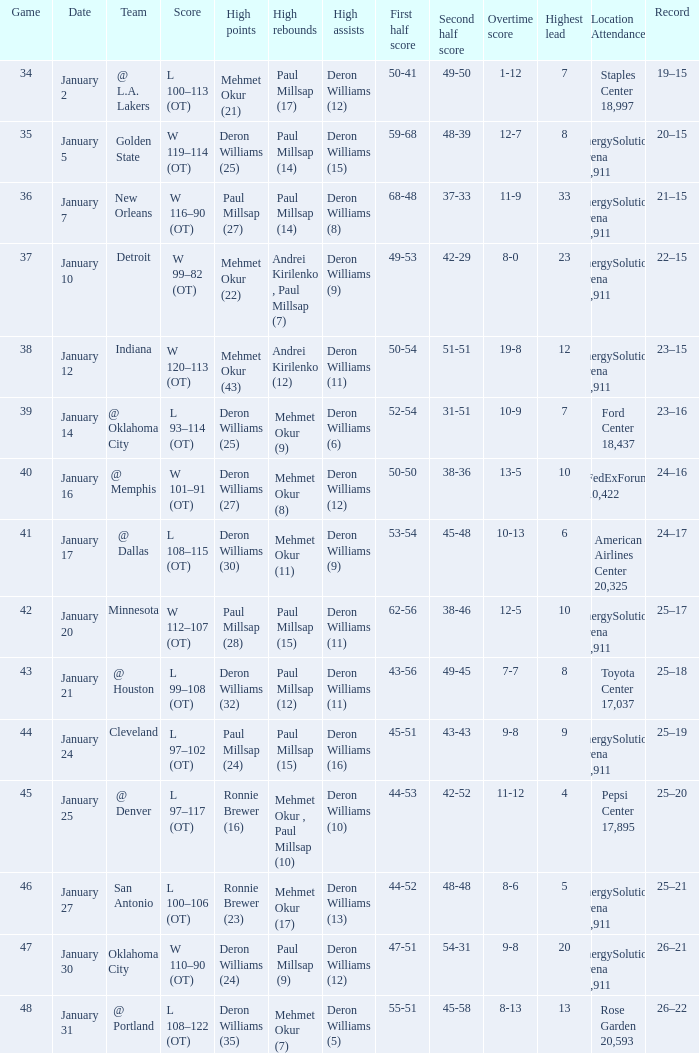Who had the high rebounds of the game that Deron Williams (5) had the high assists? Mehmet Okur (7). 